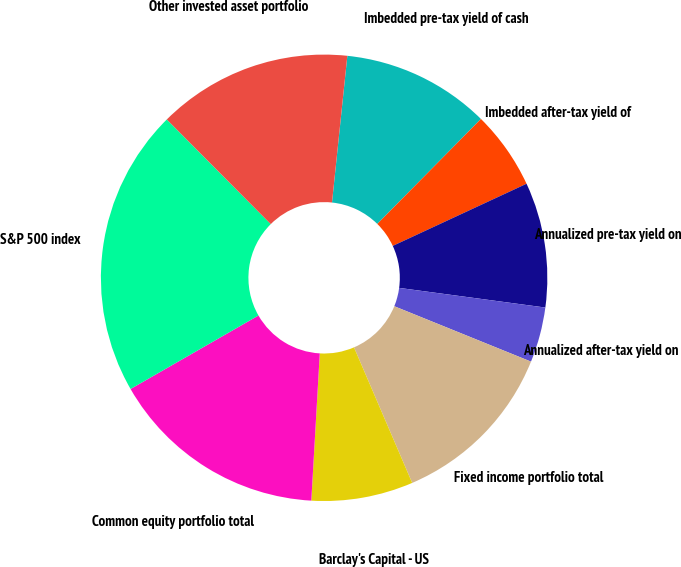<chart> <loc_0><loc_0><loc_500><loc_500><pie_chart><fcel>Imbedded pre-tax yield of cash<fcel>Imbedded after-tax yield of<fcel>Annualized pre-tax yield on<fcel>Annualized after-tax yield on<fcel>Fixed income portfolio total<fcel>Barclay's Capital - US<fcel>Common equity portfolio total<fcel>S&P 500 index<fcel>Other invested asset portfolio<nl><fcel>10.74%<fcel>5.68%<fcel>9.05%<fcel>4.0%<fcel>12.42%<fcel>7.37%<fcel>15.79%<fcel>20.85%<fcel>14.11%<nl></chart> 